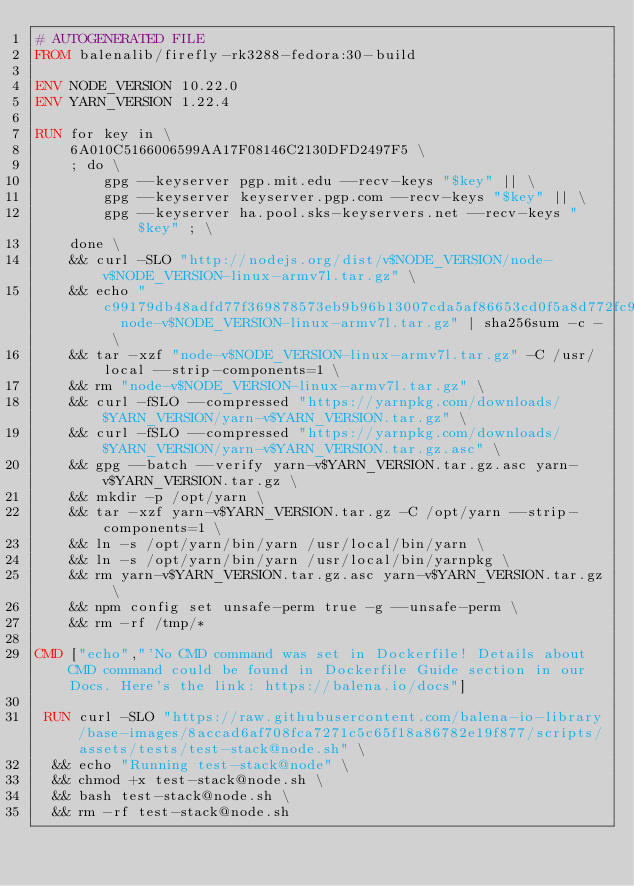<code> <loc_0><loc_0><loc_500><loc_500><_Dockerfile_># AUTOGENERATED FILE
FROM balenalib/firefly-rk3288-fedora:30-build

ENV NODE_VERSION 10.22.0
ENV YARN_VERSION 1.22.4

RUN for key in \
	6A010C5166006599AA17F08146C2130DFD2497F5 \
	; do \
		gpg --keyserver pgp.mit.edu --recv-keys "$key" || \
		gpg --keyserver keyserver.pgp.com --recv-keys "$key" || \
		gpg --keyserver ha.pool.sks-keyservers.net --recv-keys "$key" ; \
	done \
	&& curl -SLO "http://nodejs.org/dist/v$NODE_VERSION/node-v$NODE_VERSION-linux-armv7l.tar.gz" \
	&& echo "c99179db48adfd77f369878573eb9b96b13007cda5af86653cd0f5a8d772fc90  node-v$NODE_VERSION-linux-armv7l.tar.gz" | sha256sum -c - \
	&& tar -xzf "node-v$NODE_VERSION-linux-armv7l.tar.gz" -C /usr/local --strip-components=1 \
	&& rm "node-v$NODE_VERSION-linux-armv7l.tar.gz" \
	&& curl -fSLO --compressed "https://yarnpkg.com/downloads/$YARN_VERSION/yarn-v$YARN_VERSION.tar.gz" \
	&& curl -fSLO --compressed "https://yarnpkg.com/downloads/$YARN_VERSION/yarn-v$YARN_VERSION.tar.gz.asc" \
	&& gpg --batch --verify yarn-v$YARN_VERSION.tar.gz.asc yarn-v$YARN_VERSION.tar.gz \
	&& mkdir -p /opt/yarn \
	&& tar -xzf yarn-v$YARN_VERSION.tar.gz -C /opt/yarn --strip-components=1 \
	&& ln -s /opt/yarn/bin/yarn /usr/local/bin/yarn \
	&& ln -s /opt/yarn/bin/yarn /usr/local/bin/yarnpkg \
	&& rm yarn-v$YARN_VERSION.tar.gz.asc yarn-v$YARN_VERSION.tar.gz \
	&& npm config set unsafe-perm true -g --unsafe-perm \
	&& rm -rf /tmp/*

CMD ["echo","'No CMD command was set in Dockerfile! Details about CMD command could be found in Dockerfile Guide section in our Docs. Here's the link: https://balena.io/docs"]

 RUN curl -SLO "https://raw.githubusercontent.com/balena-io-library/base-images/8accad6af708fca7271c5c65f18a86782e19f877/scripts/assets/tests/test-stack@node.sh" \
  && echo "Running test-stack@node" \
  && chmod +x test-stack@node.sh \
  && bash test-stack@node.sh \
  && rm -rf test-stack@node.sh 
</code> 